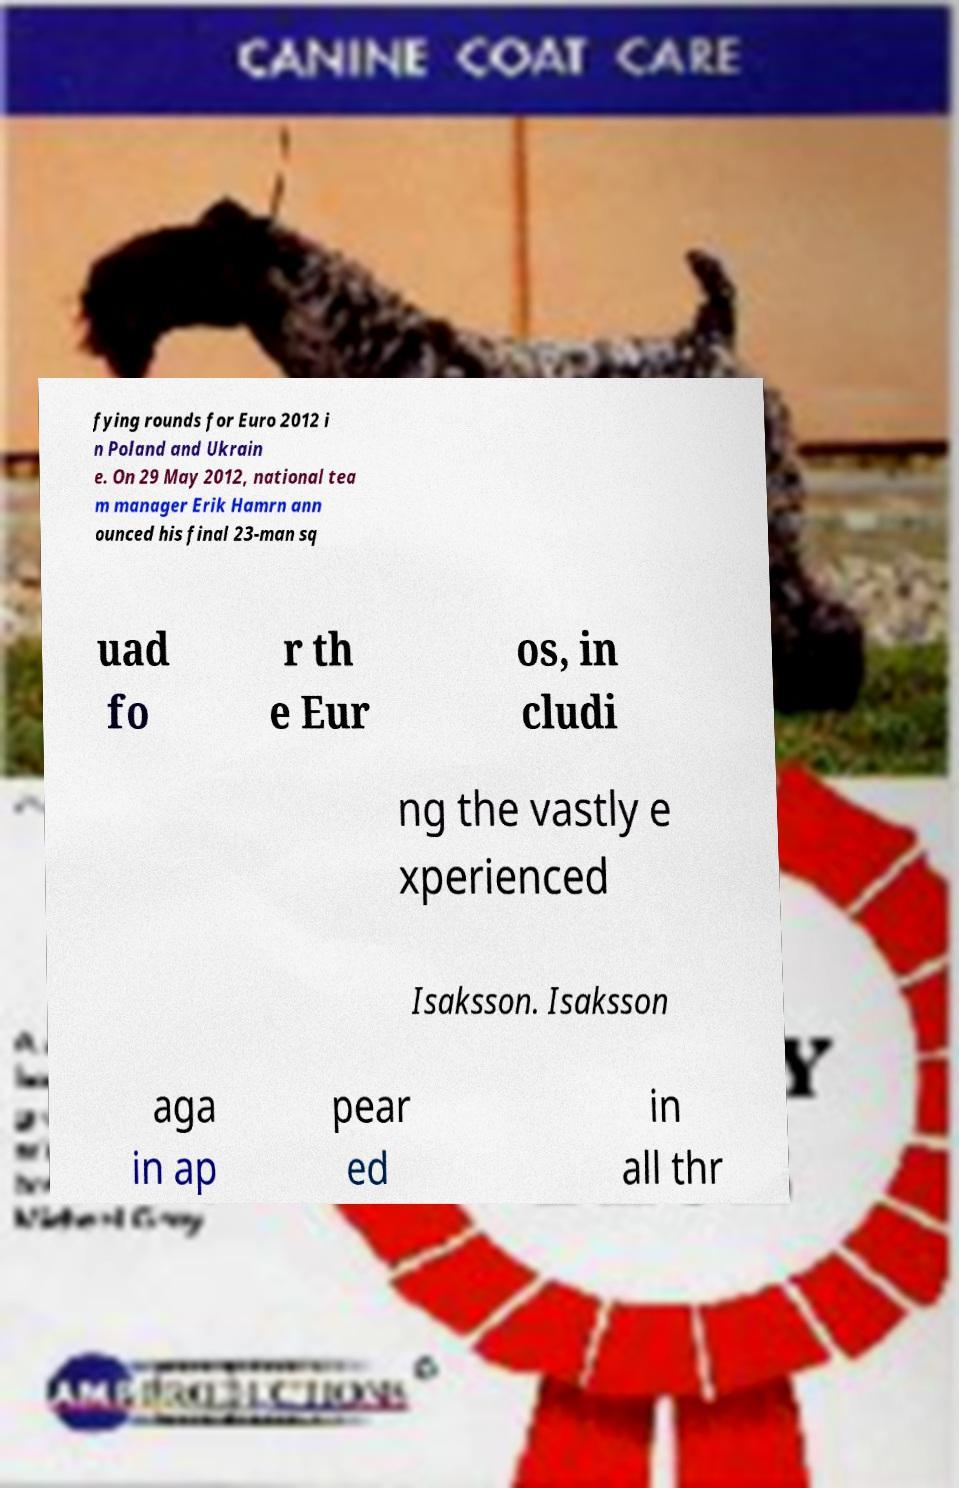I need the written content from this picture converted into text. Can you do that? fying rounds for Euro 2012 i n Poland and Ukrain e. On 29 May 2012, national tea m manager Erik Hamrn ann ounced his final 23-man sq uad fo r th e Eur os, in cludi ng the vastly e xperienced Isaksson. Isaksson aga in ap pear ed in all thr 